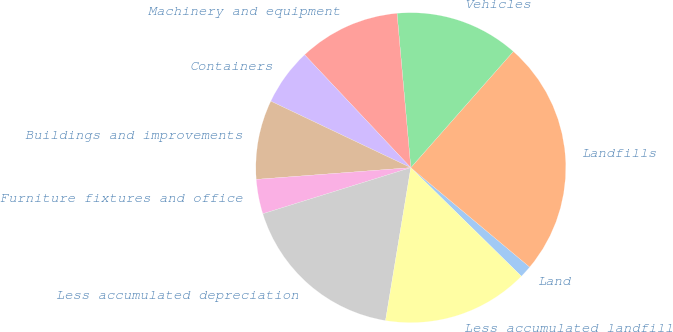Convert chart to OTSL. <chart><loc_0><loc_0><loc_500><loc_500><pie_chart><fcel>Land<fcel>Landfills<fcel>Vehicles<fcel>Machinery and equipment<fcel>Containers<fcel>Buildings and improvements<fcel>Furniture fixtures and office<fcel>Less accumulated depreciation<fcel>Less accumulated landfill<nl><fcel>1.27%<fcel>24.57%<fcel>12.92%<fcel>10.59%<fcel>5.93%<fcel>8.26%<fcel>3.6%<fcel>17.58%<fcel>15.25%<nl></chart> 